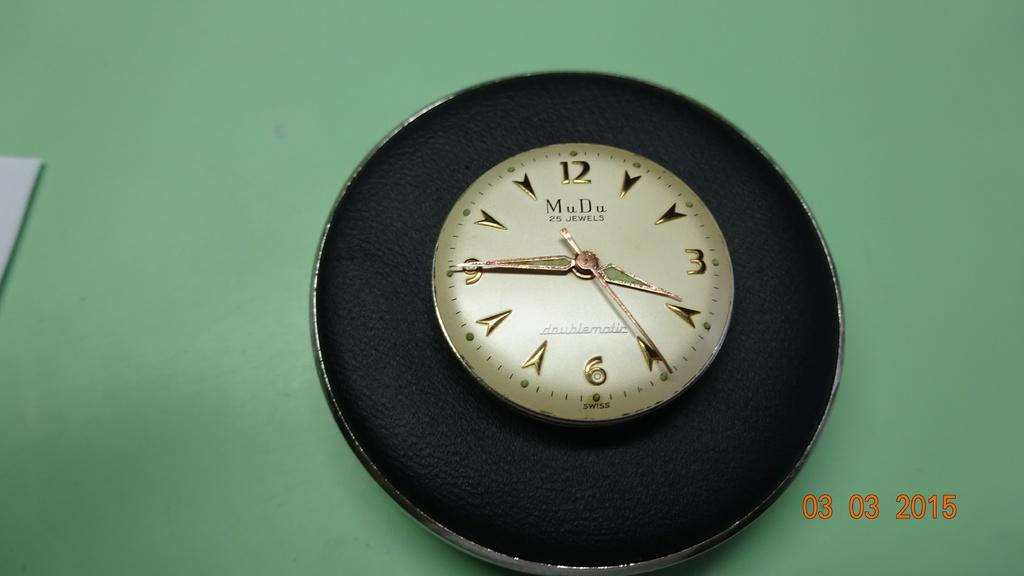What object in the image is used for telling time? There is a wall clock in the image that is used for telling time. What color is the wall in the image? The wall in the image is green. Where is the playground located in the image? There is no playground present in the image. What type of gun can be seen in the image? There is no gun present in the image. 